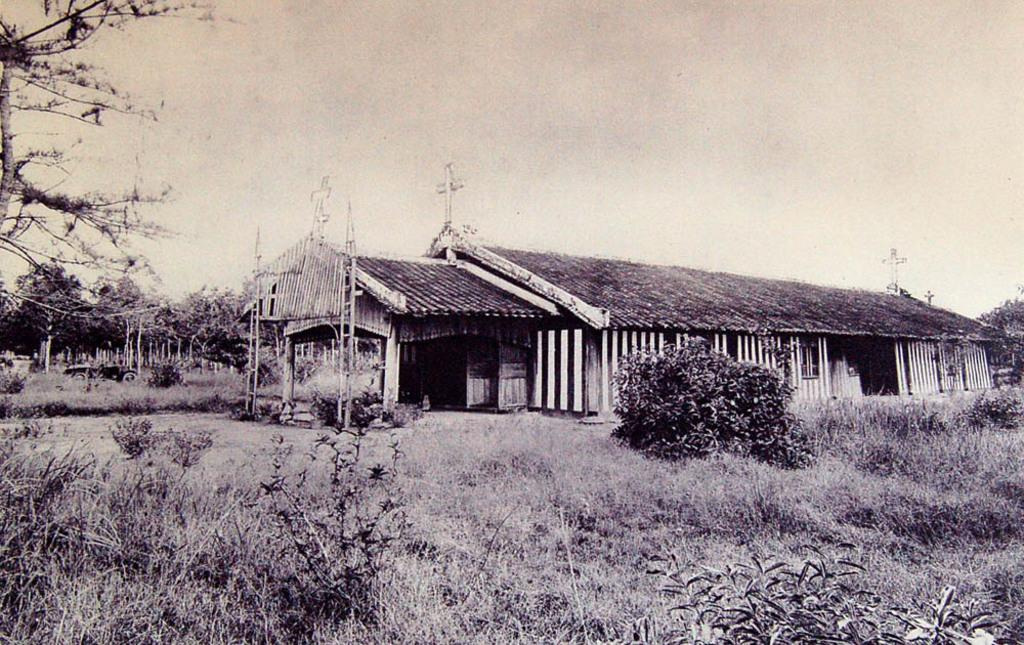What is the color scheme of the image? The image is black and white. What structure is visible in the image? There is a house in the image. What type of vegetation is present in front of the house? There is grass and plants in front of the house. What can be seen in the background of the image? There are trees, the sky, and a vehicle in the background of the image. What type of wax can be seen melting on the roof of the house in the image? There is no wax present in the image; it is a black and white image of a house with grass, plants, trees, and a vehicle in the background. 